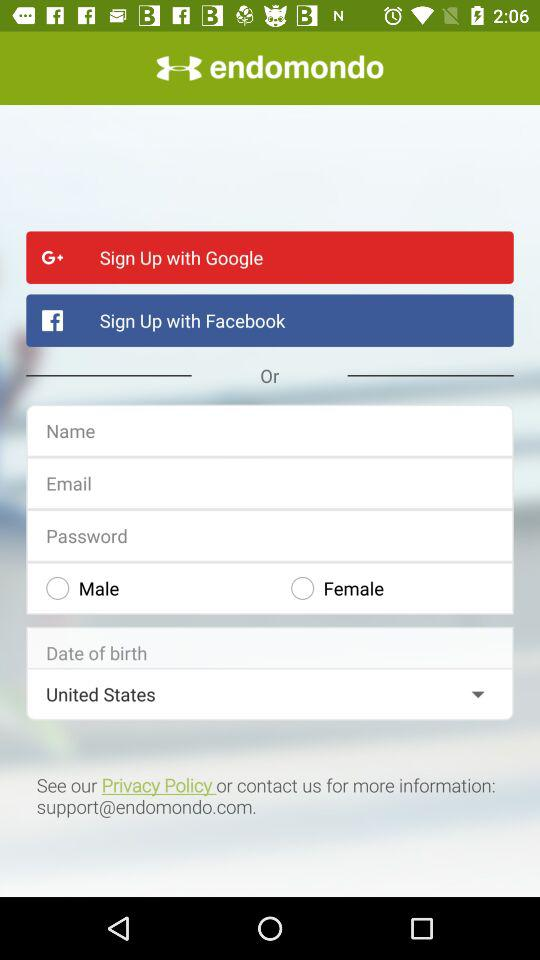Which location is selected? The selected location is the United States. 